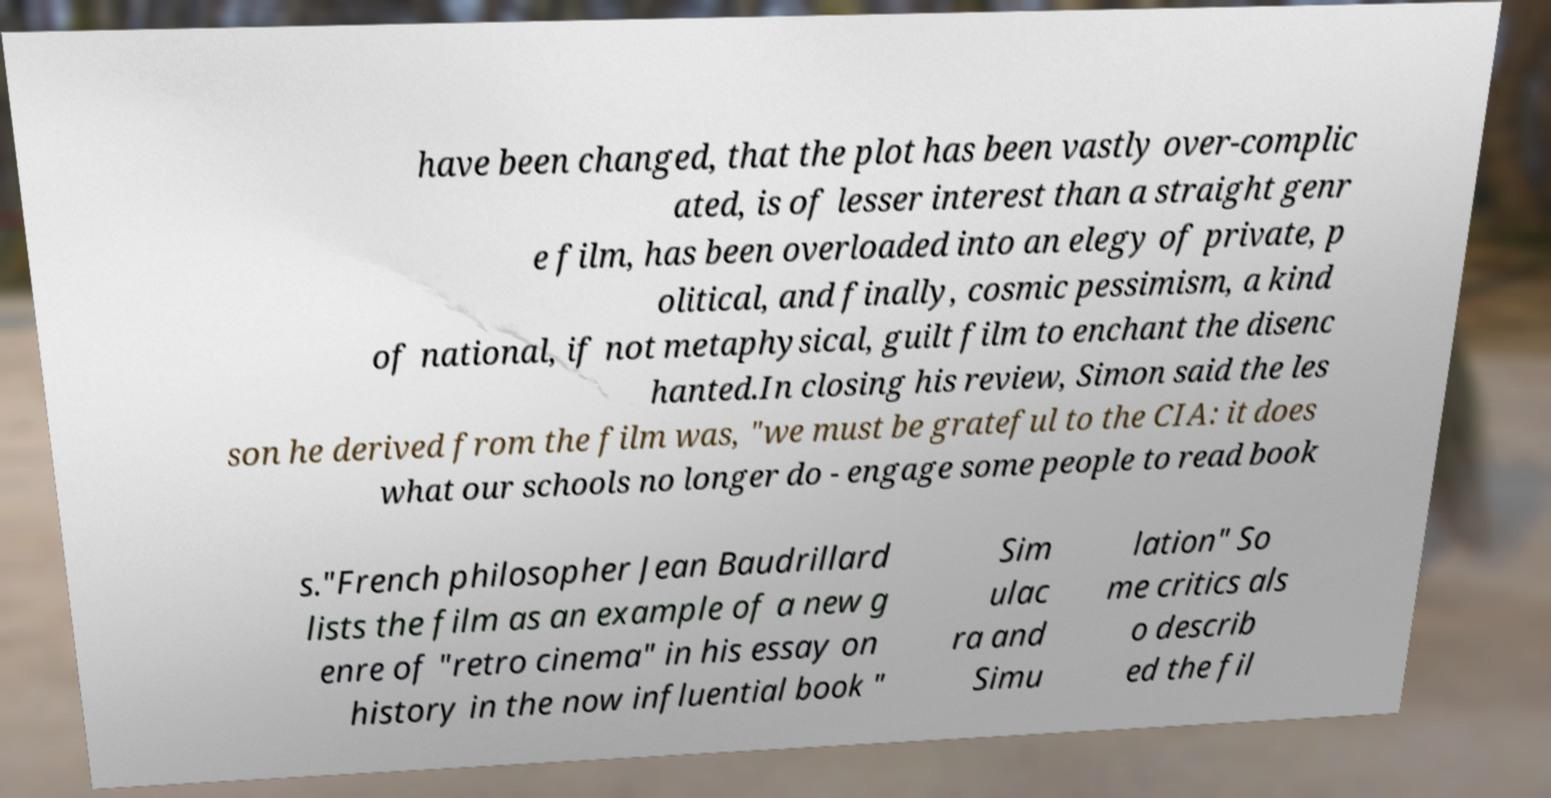Please identify and transcribe the text found in this image. have been changed, that the plot has been vastly over-complic ated, is of lesser interest than a straight genr e film, has been overloaded into an elegy of private, p olitical, and finally, cosmic pessimism, a kind of national, if not metaphysical, guilt film to enchant the disenc hanted.In closing his review, Simon said the les son he derived from the film was, "we must be grateful to the CIA: it does what our schools no longer do - engage some people to read book s."French philosopher Jean Baudrillard lists the film as an example of a new g enre of "retro cinema" in his essay on history in the now influential book " Sim ulac ra and Simu lation" So me critics als o describ ed the fil 